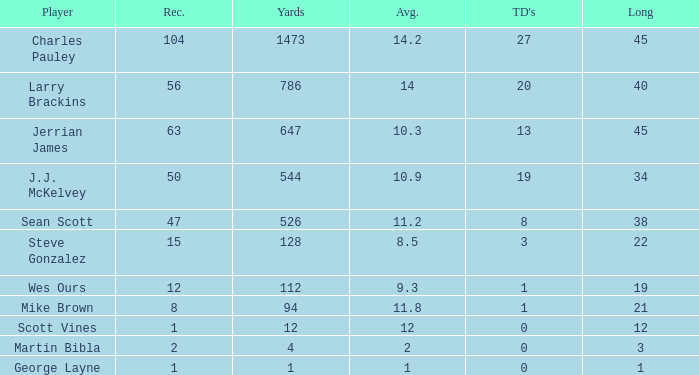Parse the table in full. {'header': ['Player', 'Rec.', 'Yards', 'Avg.', "TD's", 'Long'], 'rows': [['Charles Pauley', '104', '1473', '14.2', '27', '45'], ['Larry Brackins', '56', '786', '14', '20', '40'], ['Jerrian James', '63', '647', '10.3', '13', '45'], ['J.J. McKelvey', '50', '544', '10.9', '19', '34'], ['Sean Scott', '47', '526', '11.2', '8', '38'], ['Steve Gonzalez', '15', '128', '8.5', '3', '22'], ['Wes Ours', '12', '112', '9.3', '1', '19'], ['Mike Brown', '8', '94', '11.8', '1', '21'], ['Scott Vines', '1', '12', '12', '0', '12'], ['Martin Bibla', '2', '4', '2', '0', '3'], ['George Layne', '1', '1', '1', '0', '1']]} What's the average of wes ours when they have over 1 reception but under 1 touchdown? None. 